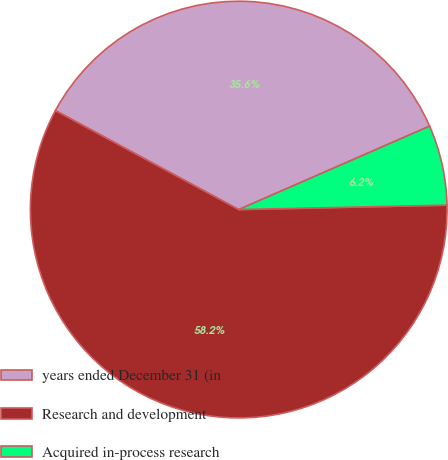Convert chart to OTSL. <chart><loc_0><loc_0><loc_500><loc_500><pie_chart><fcel>years ended December 31 (in<fcel>Research and development<fcel>Acquired in-process research<nl><fcel>35.56%<fcel>58.22%<fcel>6.22%<nl></chart> 